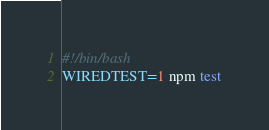<code> <loc_0><loc_0><loc_500><loc_500><_Bash_>#!/bin/bash
WIREDTEST=1 npm test
</code> 